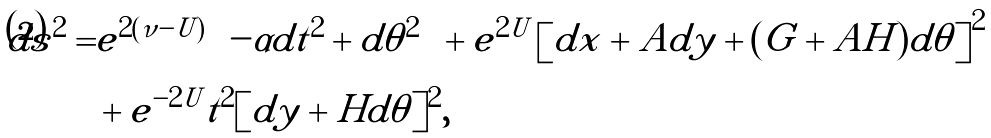<formula> <loc_0><loc_0><loc_500><loc_500>d s ^ { 2 } = & e ^ { 2 ( \nu - U ) } \left ( - \alpha d t ^ { 2 } + d \theta ^ { 2 } \right ) + e ^ { 2 U } \left [ d x + A d y + ( G + A H ) d \theta \right ] ^ { 2 } \\ & + e ^ { - 2 U } t ^ { 2 } [ d y + H d \theta ] ^ { 2 } ,</formula> 